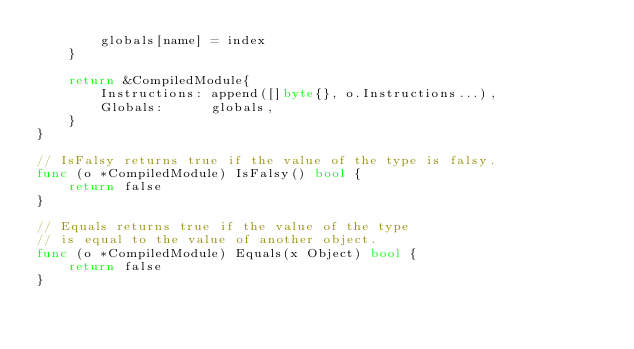<code> <loc_0><loc_0><loc_500><loc_500><_Go_>		globals[name] = index
	}

	return &CompiledModule{
		Instructions: append([]byte{}, o.Instructions...),
		Globals:      globals,
	}
}

// IsFalsy returns true if the value of the type is falsy.
func (o *CompiledModule) IsFalsy() bool {
	return false
}

// Equals returns true if the value of the type
// is equal to the value of another object.
func (o *CompiledModule) Equals(x Object) bool {
	return false
}
</code> 